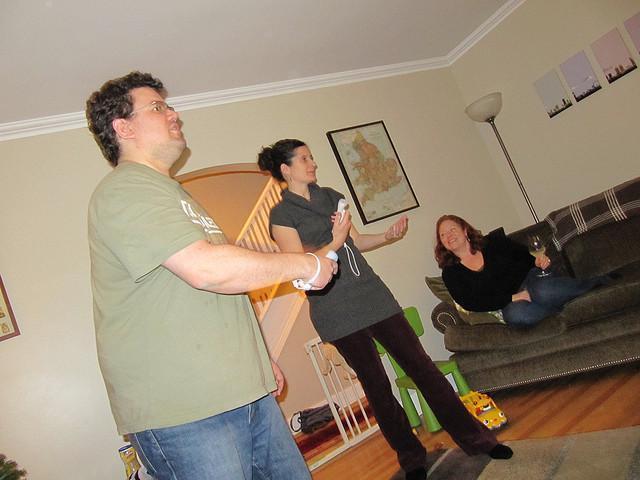How many bags are there?
Give a very brief answer. 0. How many picture frames are on the wall?
Give a very brief answer. 6. How many people can you see?
Give a very brief answer. 3. How many chairs are in the picture?
Give a very brief answer. 2. 